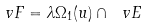<formula> <loc_0><loc_0><loc_500><loc_500>\ v F = \lambda \Omega _ { 1 } ( u ) \cap \ v E</formula> 